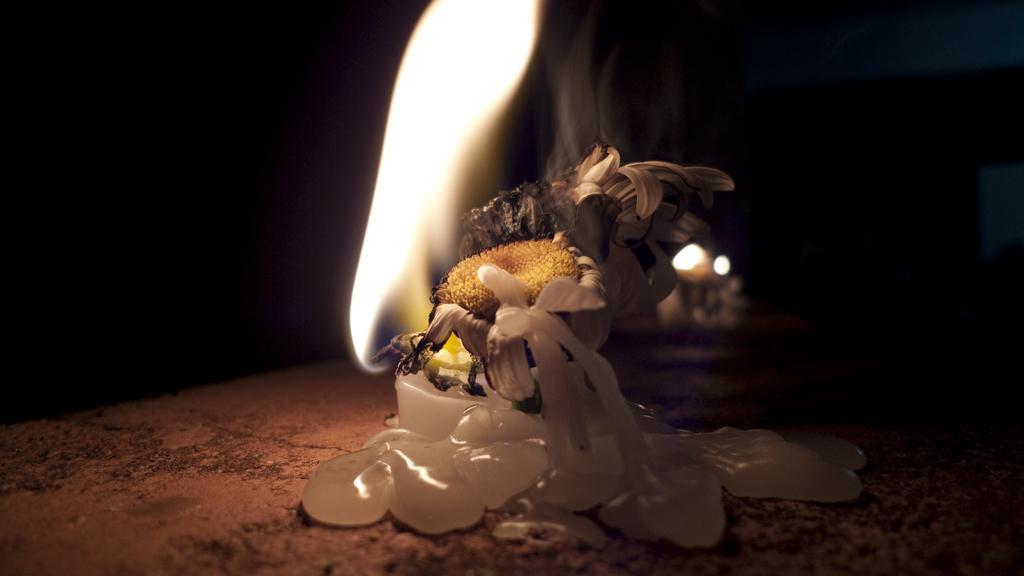How would you summarize this image in a sentence or two? In this image there is a sunflower and a candle on the path, and there is dark background. 